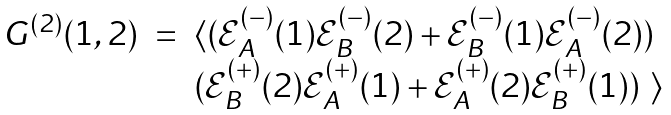Convert formula to latex. <formula><loc_0><loc_0><loc_500><loc_500>\begin{array} { c c l } G ^ { ( 2 ) } ( 1 , 2 ) & = & \langle ( \mathcal { E } ^ { ( - ) } _ { A } ( 1 ) \mathcal { E } ^ { ( - ) } _ { B } ( 2 ) + \mathcal { E } ^ { ( - ) } _ { B } ( 1 ) \mathcal { E } ^ { ( - ) } _ { A } ( 2 ) ) \\ & & ( \mathcal { E } ^ { ( + ) } _ { B } ( 2 ) \mathcal { E } ^ { ( + ) } _ { A } ( 1 ) + \mathcal { E } ^ { ( + ) } _ { A } ( 2 ) \mathcal { E } ^ { ( + ) } _ { B } ( 1 ) ) \ \rangle \end{array}</formula> 